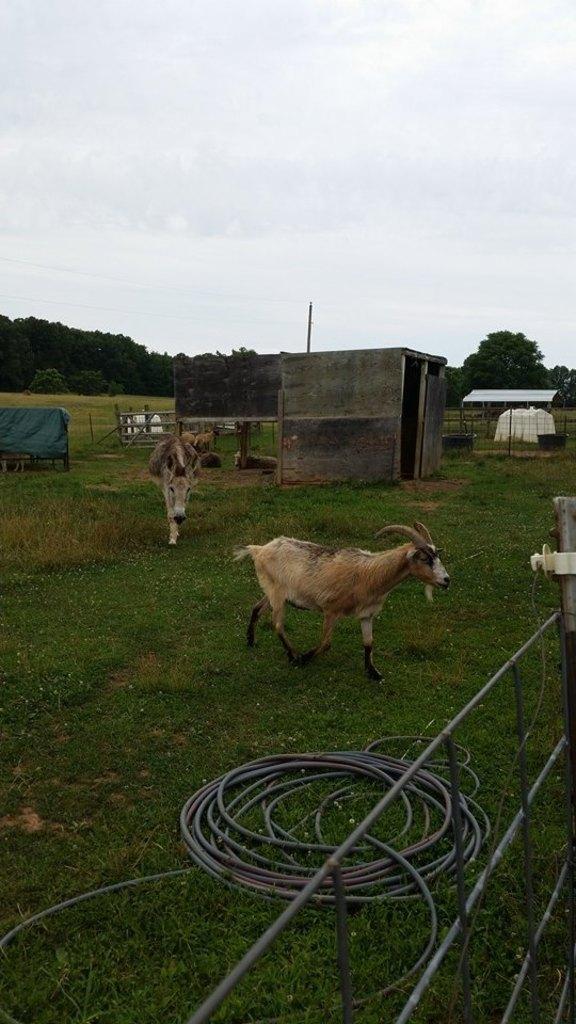How would you summarize this image in a sentence or two? In the image there is a goat and a donkey standing on the grassland inside a fence, there is a pipe in the front and in the back it seems to be a shed and over the whole background there are trees and above its sky with clouds. 